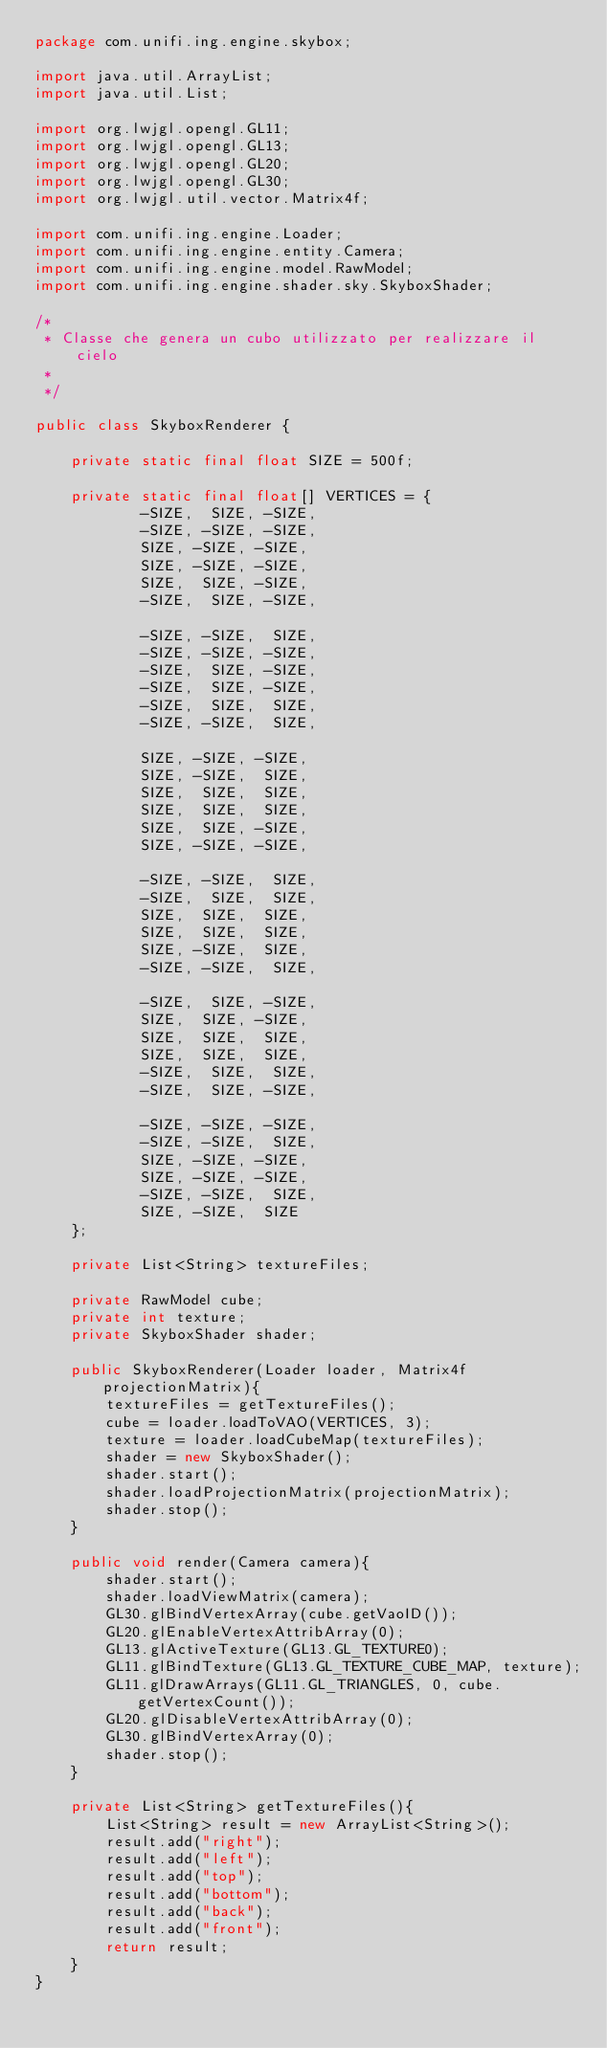Convert code to text. <code><loc_0><loc_0><loc_500><loc_500><_Java_>package com.unifi.ing.engine.skybox;

import java.util.ArrayList;
import java.util.List;

import org.lwjgl.opengl.GL11;
import org.lwjgl.opengl.GL13;
import org.lwjgl.opengl.GL20;
import org.lwjgl.opengl.GL30;
import org.lwjgl.util.vector.Matrix4f;

import com.unifi.ing.engine.Loader;
import com.unifi.ing.engine.entity.Camera;
import com.unifi.ing.engine.model.RawModel;
import com.unifi.ing.engine.shader.sky.SkyboxShader;

/*
 * Classe che genera un cubo utilizzato per realizzare il cielo
 * 
 */

public class SkyboxRenderer {

	private static final float SIZE = 500f;

	private static final float[] VERTICES = {        
			-SIZE,  SIZE, -SIZE,
			-SIZE, -SIZE, -SIZE,
			SIZE, -SIZE, -SIZE,
			SIZE, -SIZE, -SIZE,
			SIZE,  SIZE, -SIZE,
			-SIZE,  SIZE, -SIZE,

			-SIZE, -SIZE,  SIZE,
			-SIZE, -SIZE, -SIZE,
			-SIZE,  SIZE, -SIZE,
			-SIZE,  SIZE, -SIZE,
			-SIZE,  SIZE,  SIZE,
			-SIZE, -SIZE,  SIZE,

			SIZE, -SIZE, -SIZE,
			SIZE, -SIZE,  SIZE,
			SIZE,  SIZE,  SIZE,
			SIZE,  SIZE,  SIZE,
			SIZE,  SIZE, -SIZE,
			SIZE, -SIZE, -SIZE,

			-SIZE, -SIZE,  SIZE,
			-SIZE,  SIZE,  SIZE,
			SIZE,  SIZE,  SIZE,
			SIZE,  SIZE,  SIZE,
			SIZE, -SIZE,  SIZE,
			-SIZE, -SIZE,  SIZE,

			-SIZE,  SIZE, -SIZE,
			SIZE,  SIZE, -SIZE,
			SIZE,  SIZE,  SIZE,
			SIZE,  SIZE,  SIZE,
			-SIZE,  SIZE,  SIZE,
			-SIZE,  SIZE, -SIZE,

			-SIZE, -SIZE, -SIZE,
			-SIZE, -SIZE,  SIZE,
			SIZE, -SIZE, -SIZE,
			SIZE, -SIZE, -SIZE,
			-SIZE, -SIZE,  SIZE,
			SIZE, -SIZE,  SIZE
	};

	private List<String> textureFiles;
	
	private RawModel cube;
	private int texture;
	private SkyboxShader shader;
	
	public SkyboxRenderer(Loader loader, Matrix4f projectionMatrix){
		textureFiles = getTextureFiles();
		cube = loader.loadToVAO(VERTICES, 3);
		texture = loader.loadCubeMap(textureFiles);
		shader = new SkyboxShader();
		shader.start();
		shader.loadProjectionMatrix(projectionMatrix);
		shader.stop();
	}
	
	public void render(Camera camera){
		shader.start();
		shader.loadViewMatrix(camera);
		GL30.glBindVertexArray(cube.getVaoID());
		GL20.glEnableVertexAttribArray(0);
		GL13.glActiveTexture(GL13.GL_TEXTURE0);
		GL11.glBindTexture(GL13.GL_TEXTURE_CUBE_MAP, texture);
		GL11.glDrawArrays(GL11.GL_TRIANGLES, 0, cube.getVertexCount());
		GL20.glDisableVertexAttribArray(0);
		GL30.glBindVertexArray(0);
		shader.stop();
	}
	
	private List<String> getTextureFiles(){
		List<String> result = new ArrayList<String>();
		result.add("right");
		result.add("left");
		result.add("top");
		result.add("bottom");
		result.add("back");
		result.add("front");
		return result;
	}
}
</code> 